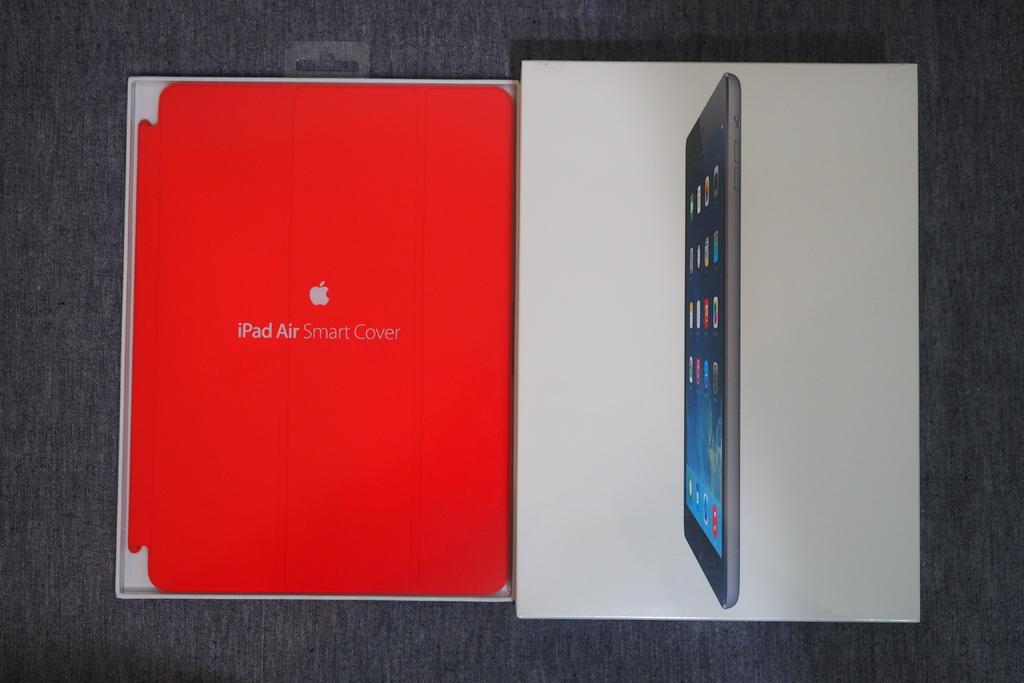<image>
Offer a succinct explanation of the picture presented. An iPad Air Smart Cover is in its box. 